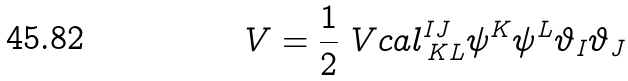Convert formula to latex. <formula><loc_0><loc_0><loc_500><loc_500>V = \frac { 1 } { 2 } \ V c a l ^ { I J } _ { \, K L } \psi ^ { K } \psi ^ { L } \vartheta _ { I } \vartheta _ { J }</formula> 